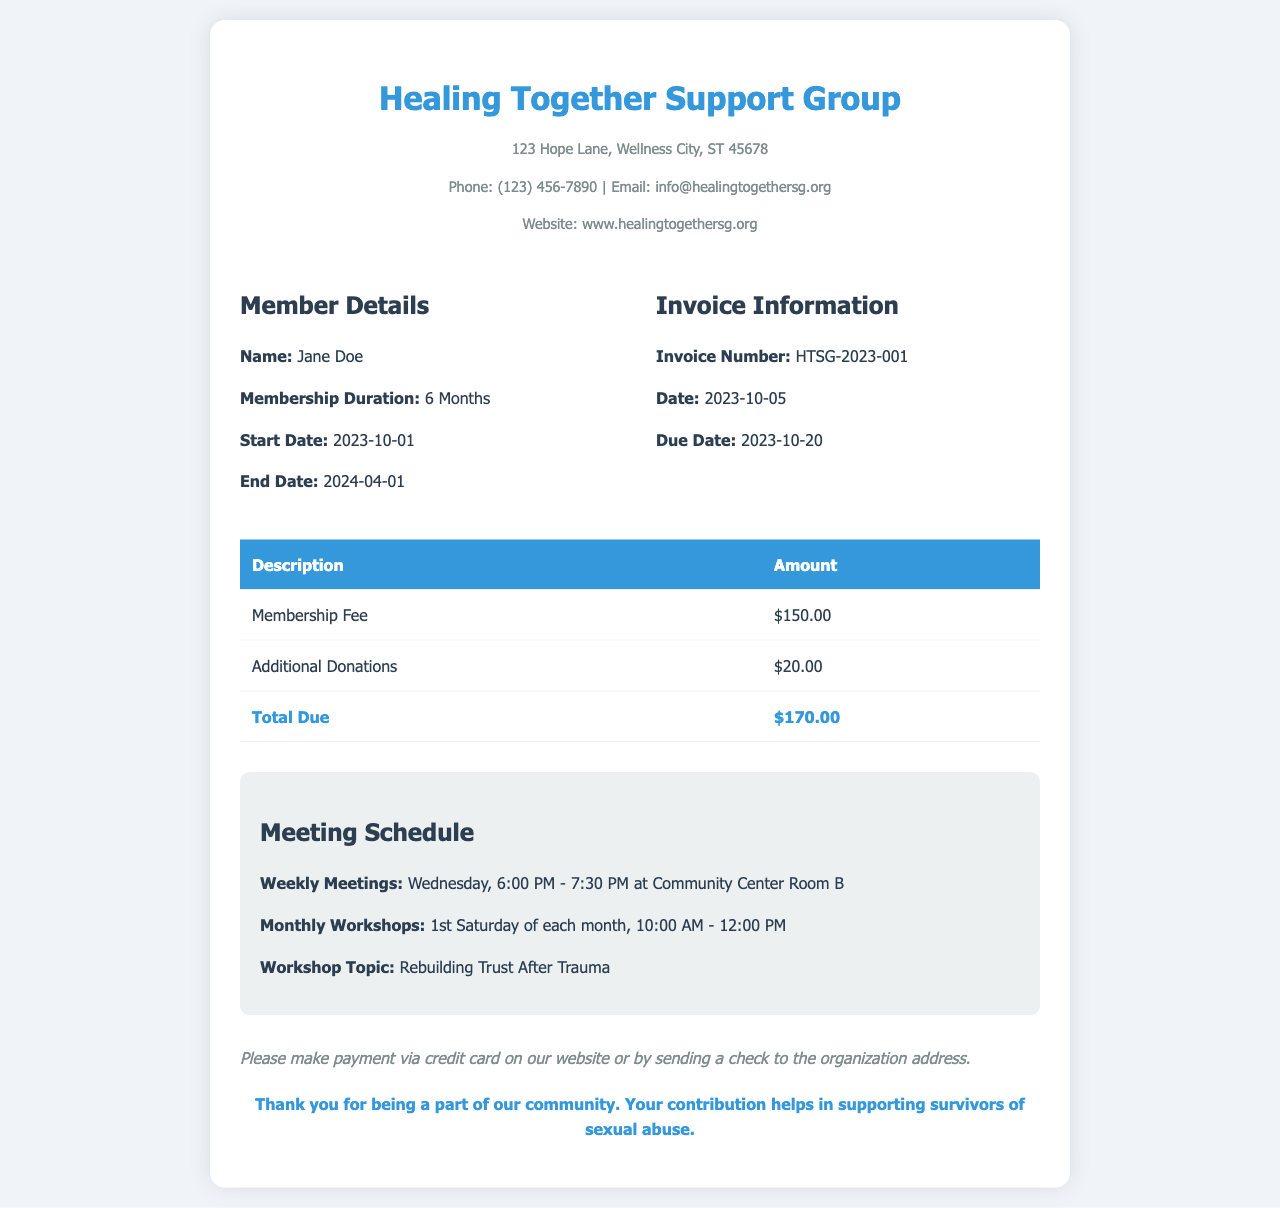What is the name of the support group? The name of the support group is mentioned at the top of the invoice.
Answer: Healing Together Support Group What is the membership duration? The membership duration is specified in the member details section.
Answer: 6 Months What is the total amount due? The total amount due is calculated at the bottom of the invoice table.
Answer: $170.00 When does the membership end? The end date of the membership is provided in the member details section.
Answer: 2024-04-01 What is the invoice number? The invoice number is listed in the invoice information section.
Answer: HTSG-2023-001 What day of the week are the weekly meetings held? The schedule specifies the day of the week for weekly meetings.
Answer: Wednesday What is the amount for additional donations? The invoice table lists the amount for additional donations.
Answer: $20.00 What workshop topic is mentioned? The workshop topic is provided in the meeting schedule section.
Answer: Rebuilding Trust After Trauma When is the due date for the invoice? The due date is specified in the invoice information section.
Answer: 2023-10-20 